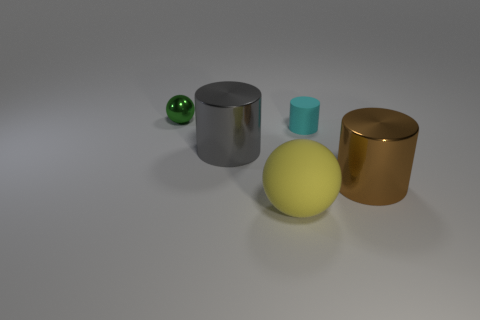Add 3 tiny green things. How many objects exist? 8 Subtract all cylinders. How many objects are left? 2 Subtract all small brown things. Subtract all brown things. How many objects are left? 4 Add 2 cylinders. How many cylinders are left? 5 Add 4 large things. How many large things exist? 7 Subtract 0 purple blocks. How many objects are left? 5 